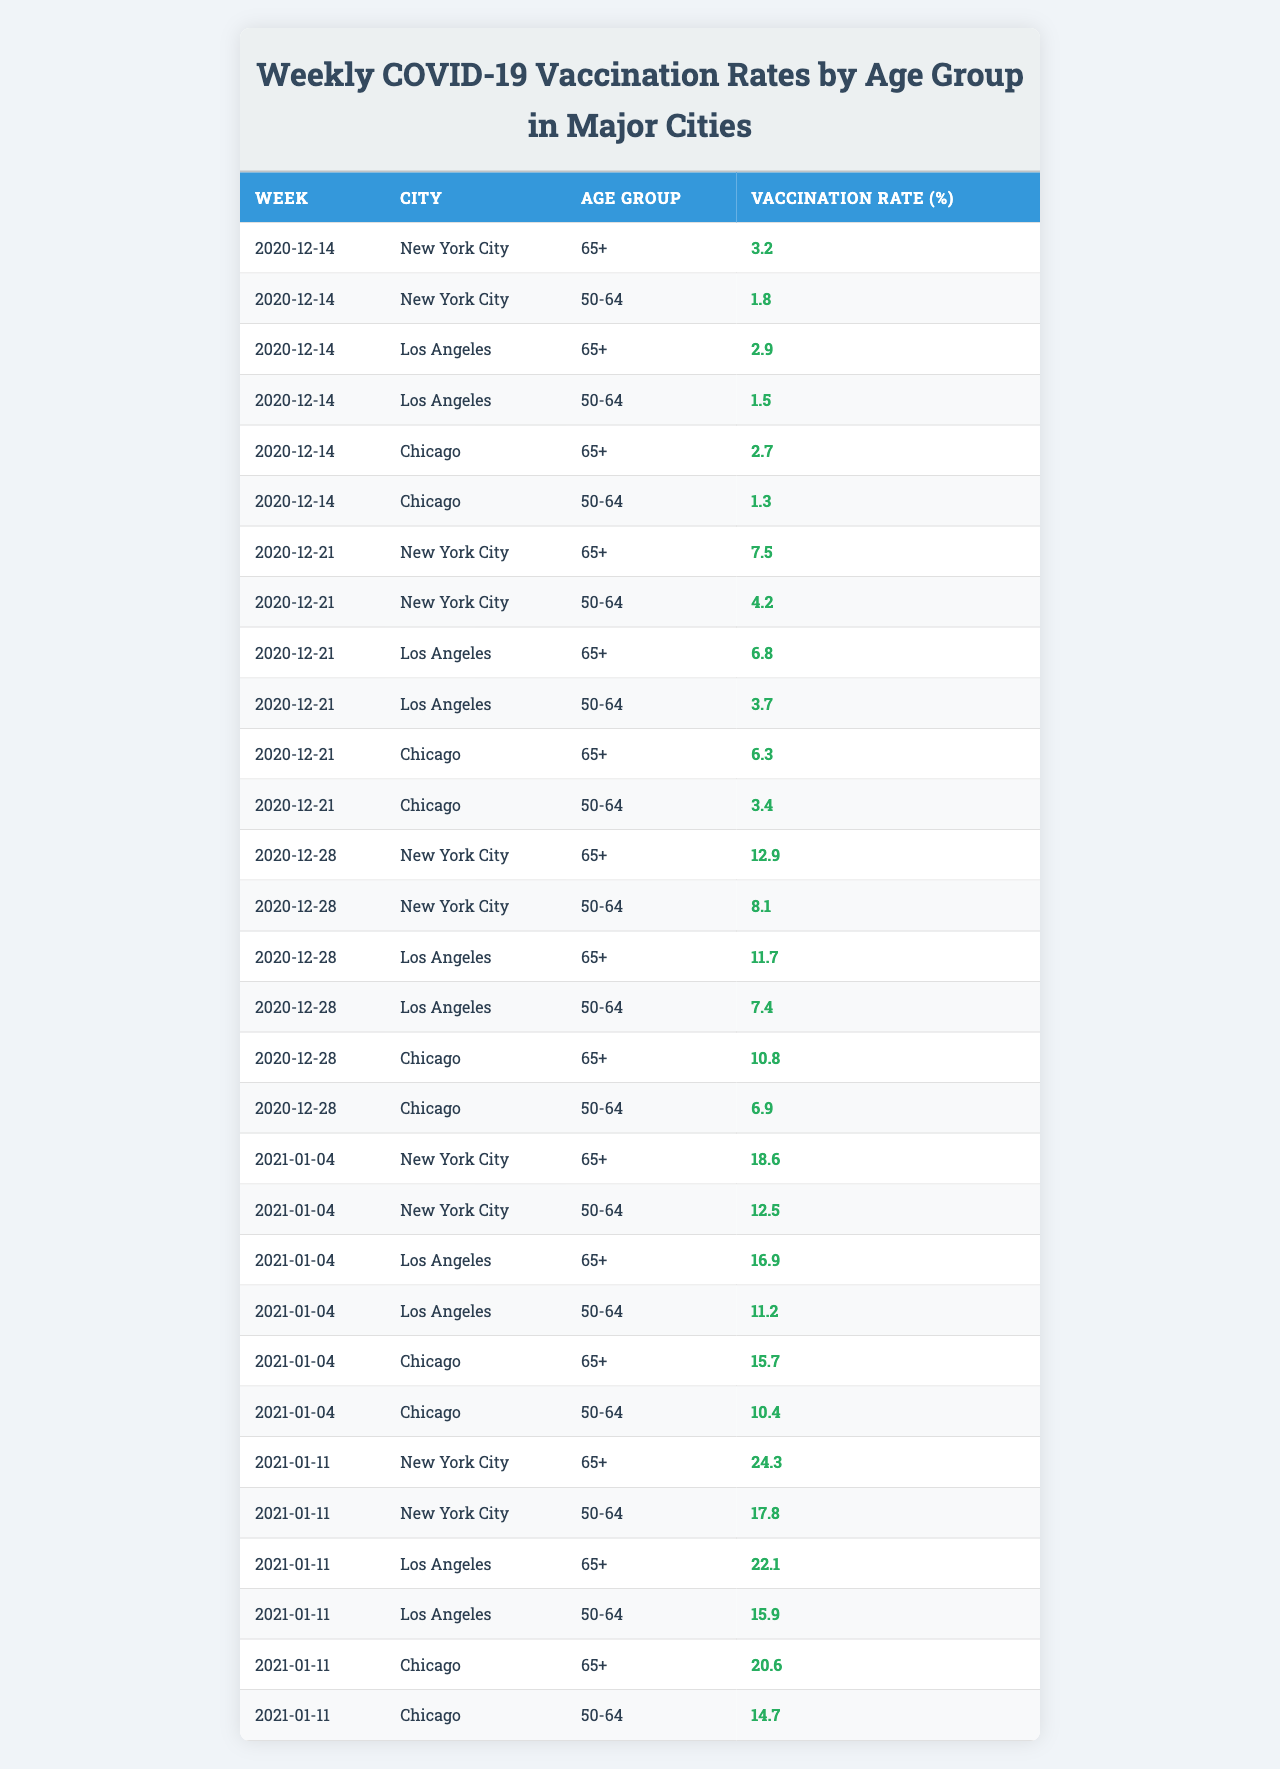What was the vaccination rate for the 50-64 age group in Los Angeles on December 14, 2020? The table shows that on December 14, 2020, Los Angeles had a vaccination rate of 1.5% for the 50-64 age group.
Answer: 1.5% Which city had the highest vaccination rate for the 65+ age group in the week of January 11, 2021? According to the table, New York City had the highest vaccination rate of 24.3% for the 65+ age group in the week of January 11, 2021.
Answer: New York City What was the average vaccination rate for the 50-64 age group across all cities on December 28, 2020? For the 50-64 age group on December 28, 2020, the vaccination rates are 8.1% (NYC), 7.4% (Los Angeles), and 6.9% (Chicago). The average is calculated as (8.1 + 7.4 + 6.9) / 3 = 7.47%.
Answer: 7.47% Did the vaccination rate for the 65+ age group increase in New York City from December 21, 2020, to December 28, 2020? The table indicates that the vaccination rate for the 65+ age group in New York City was 7.5% on December 21 and increased to 12.9% on December 28. This confirms that the rate increased.
Answer: Yes Which age group in Chicago had the lowest vaccination rate on January 4, 2021? The table shows that on January 4, 2021, the 50-64 age group in Chicago had a vaccination rate of 10.4%, which is lower than the 65+ age group's rate of 15.7%.
Answer: 50-64 age group By how much did the vaccination rate for the 50-64 age group in New York City change from December 14, 2020, to January 11, 2021? On December 14, 2020, the vaccination rate for the 50-64 age group in New York City was 1.8%, and by January 11, 2021, it had increased to 17.8%. The change is calculated as 17.8 - 1.8 = 16%.
Answer: 16% Which age group had a higher vaccination rate in Los Angeles during the entire observed period? By reviewing the data for Los Angeles throughout the observed weeks, the vaccination rates for the 65+ age group (peaking at 16.9%) were consistently higher than for the 50-64 age group (peaking at 15.9%).
Answer: 65+ age group Find the total vaccination rate for the 65+ age group in Chicago from December 14, 2020, to January 11, 2021. The vaccination rates for the 65+ age group in Chicago during that time were 2.7% (Dec 14), 6.3% (Dec 21), 10.8% (Dec 28), 15.7% (Jan 4), and 20.6% (Jan 11). Summing these gives 2.7 + 6.3 + 10.8 + 15.7 + 20.6 = 56.1%.
Answer: 56.1% 